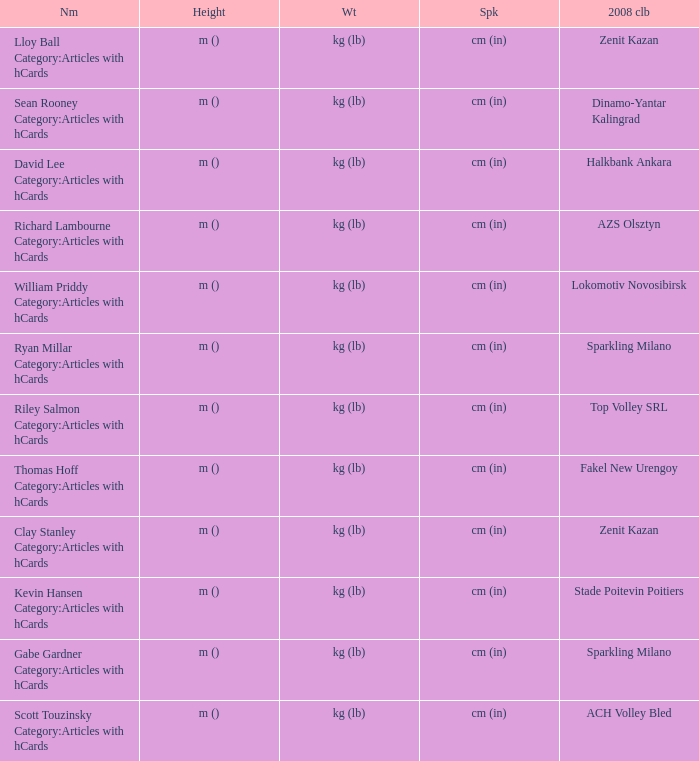What shows for height for the 2008 club of Stade Poitevin Poitiers? M (). 